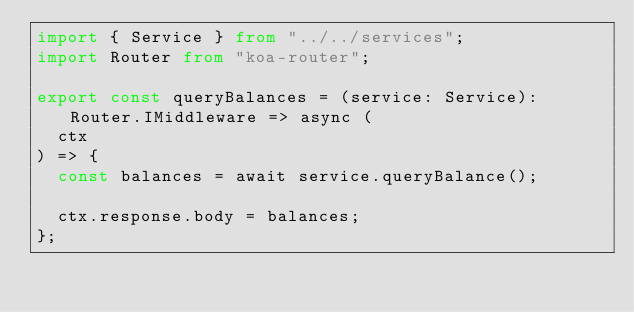<code> <loc_0><loc_0><loc_500><loc_500><_TypeScript_>import { Service } from "../../services";
import Router from "koa-router";

export const queryBalances = (service: Service): Router.IMiddleware => async (
  ctx
) => {
  const balances = await service.queryBalance();

  ctx.response.body = balances;
};
</code> 